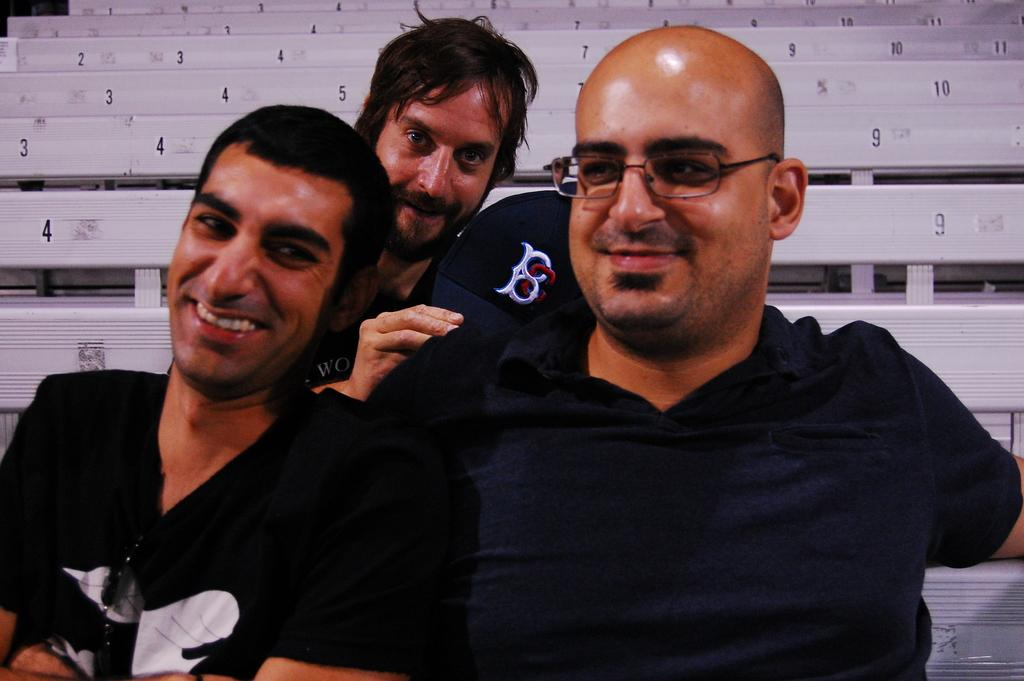What are the people in the image doing? The people in the image are sitting on benches. How many benches can be seen in the image? There are benches visible in the background of the image as well, so there are at least two benches in total. What type of loaf is being used as a seat cushion on the benches in the image? There is no loaf present in the image; the benches are being used as intended for sitting. 